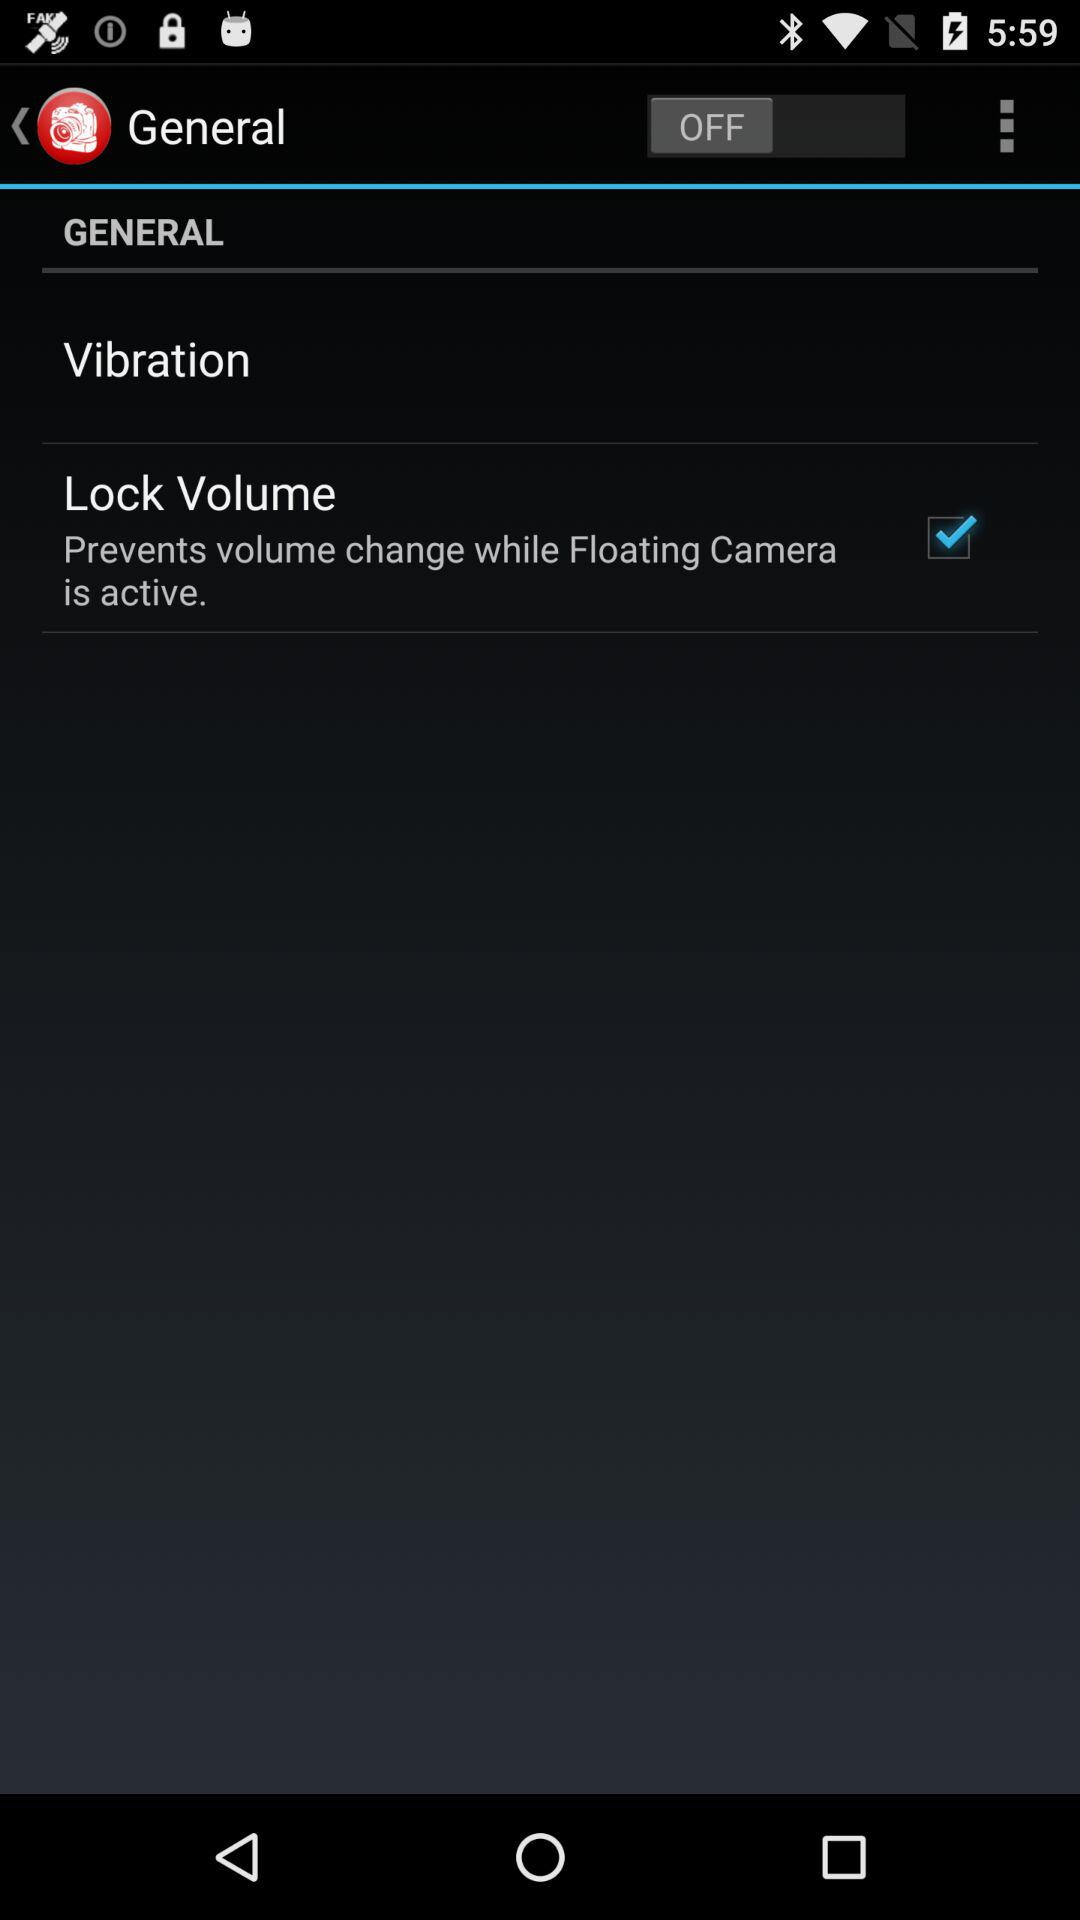Which option is checked? The checked option is "Lock Volume". 